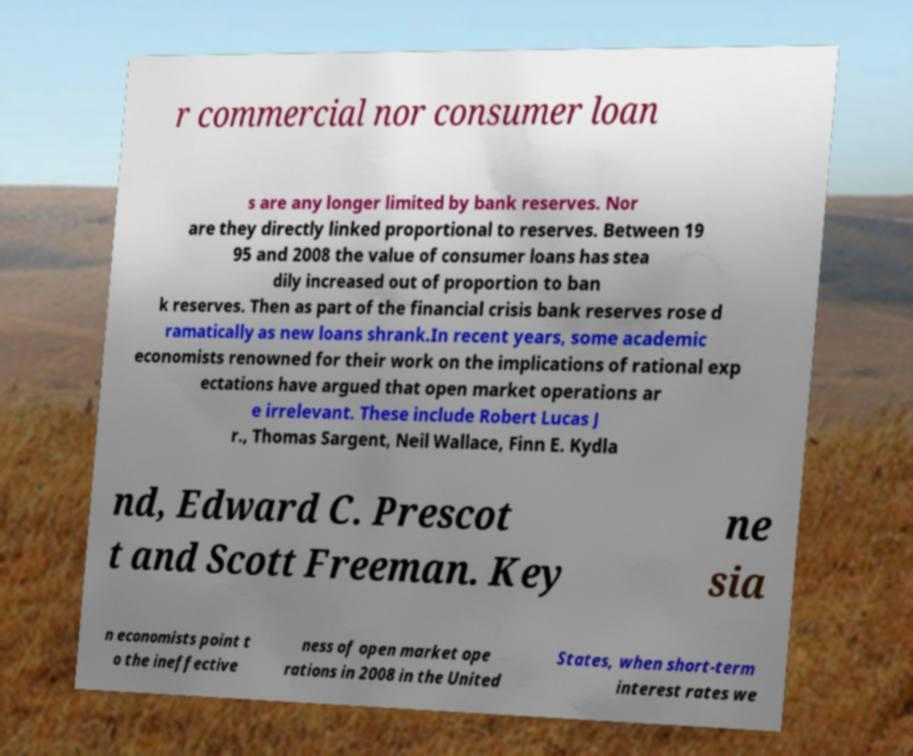Please read and relay the text visible in this image. What does it say? r commercial nor consumer loan s are any longer limited by bank reserves. Nor are they directly linked proportional to reserves. Between 19 95 and 2008 the value of consumer loans has stea dily increased out of proportion to ban k reserves. Then as part of the financial crisis bank reserves rose d ramatically as new loans shrank.In recent years, some academic economists renowned for their work on the implications of rational exp ectations have argued that open market operations ar e irrelevant. These include Robert Lucas J r., Thomas Sargent, Neil Wallace, Finn E. Kydla nd, Edward C. Prescot t and Scott Freeman. Key ne sia n economists point t o the ineffective ness of open market ope rations in 2008 in the United States, when short-term interest rates we 